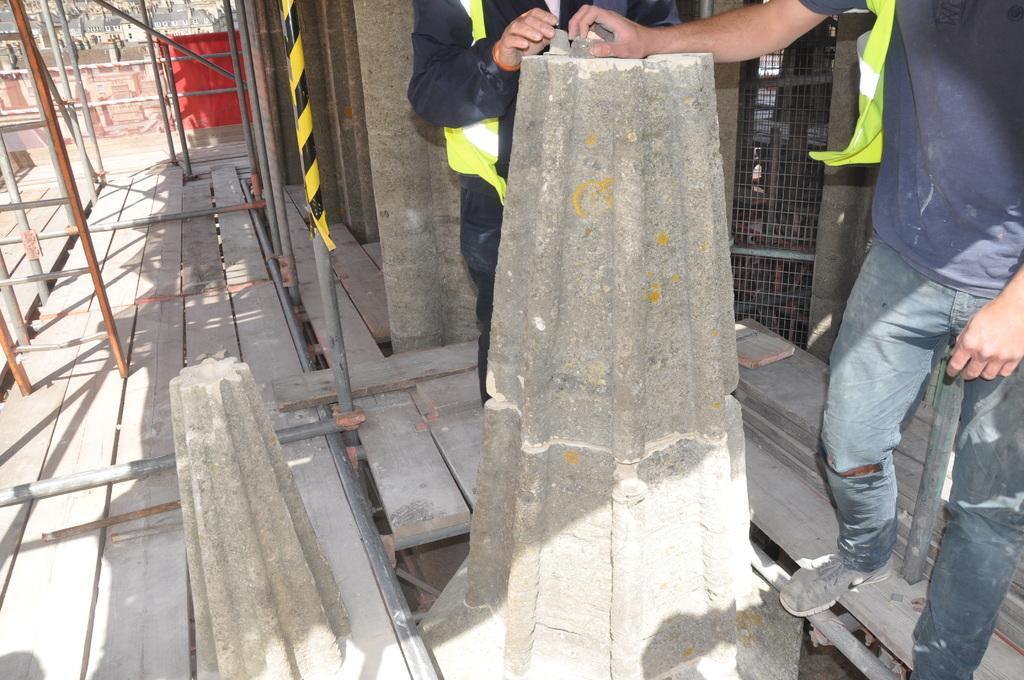Please provide a concise description of this image. In this image we can see two men standing on the ground. We can also see some concrete poles, the metal rods, a mesh, a curtain and a fence. On the backside we can see some buildings. 